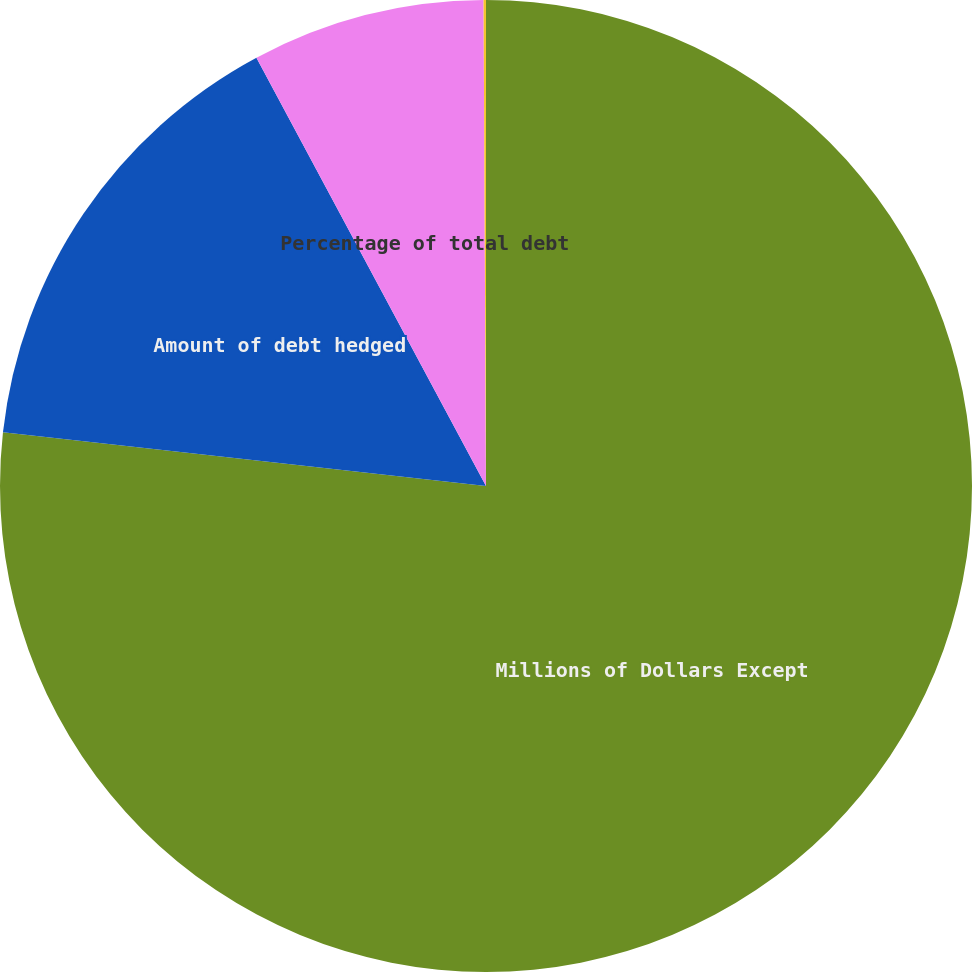Convert chart. <chart><loc_0><loc_0><loc_500><loc_500><pie_chart><fcel>Millions of Dollars Except<fcel>Amount of debt hedged<fcel>Percentage of total debt<fcel>Gross fair value<nl><fcel>76.76%<fcel>15.41%<fcel>7.75%<fcel>0.08%<nl></chart> 